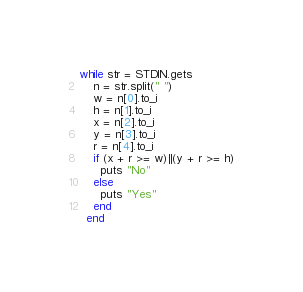Convert code to text. <code><loc_0><loc_0><loc_500><loc_500><_Ruby_>while str = STDIN.gets
    n = str.split(" ")
    w = n[0].to_i
    h = n[1].to_i
    x = n[2].to_i
    y = n[3].to_i
    r = n[4].to_i
    if (x + r >= w)||(y + r >= h)
      puts "No"
    else
      puts "Yes"
    end
  end</code> 